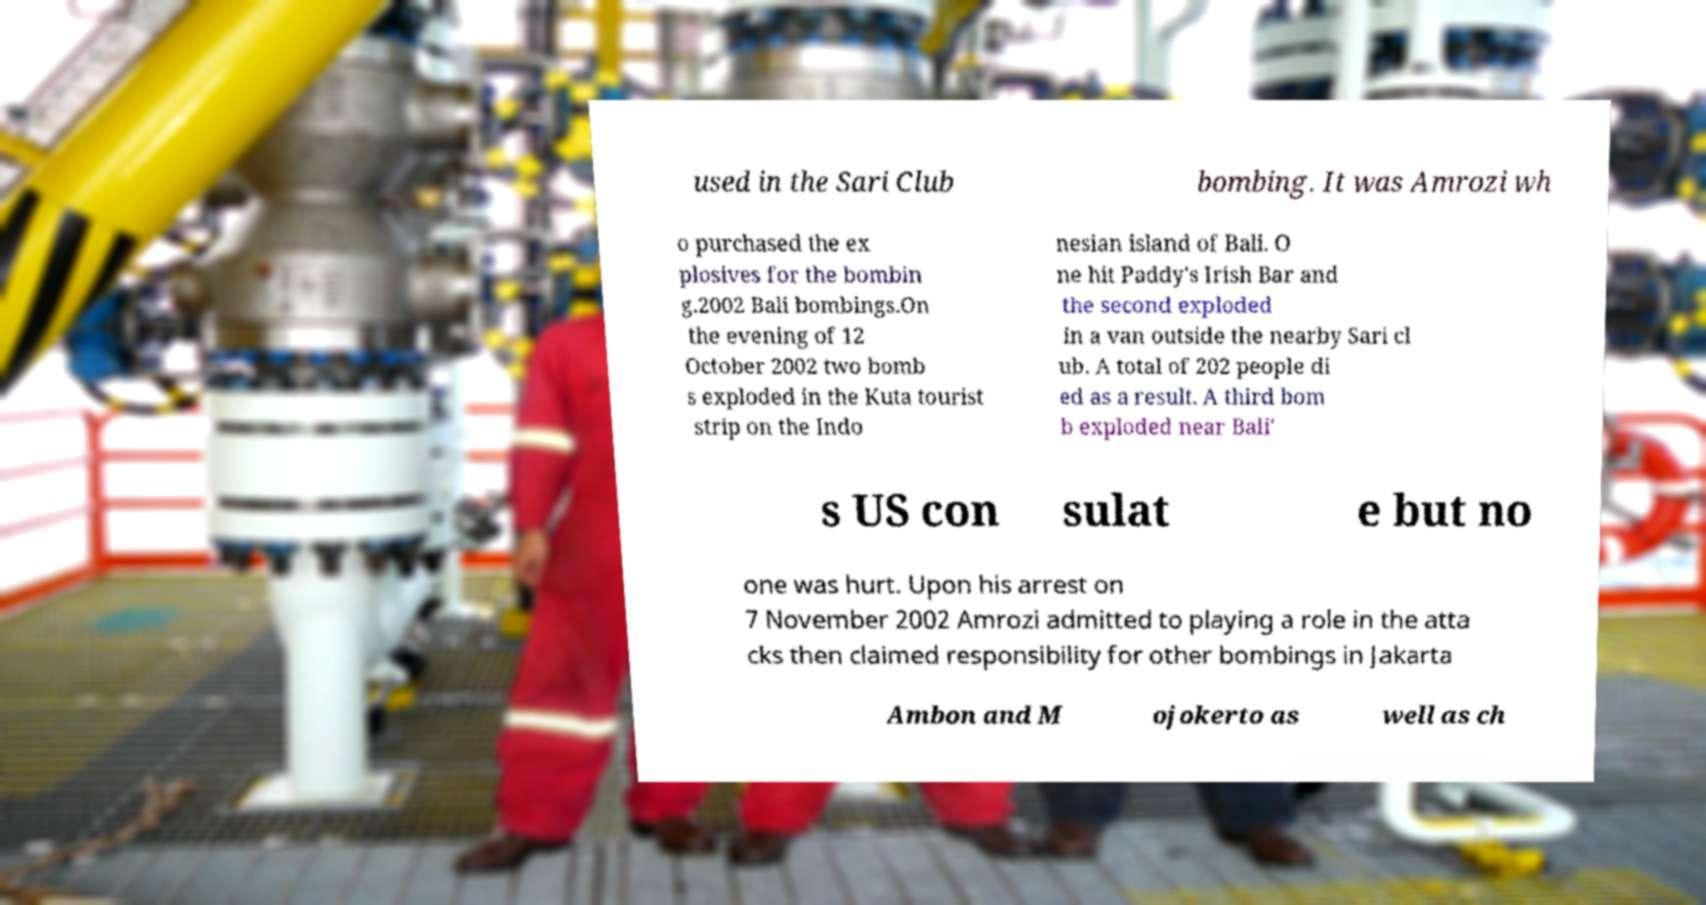Could you assist in decoding the text presented in this image and type it out clearly? used in the Sari Club bombing. It was Amrozi wh o purchased the ex plosives for the bombin g.2002 Bali bombings.On the evening of 12 October 2002 two bomb s exploded in the Kuta tourist strip on the Indo nesian island of Bali. O ne hit Paddy's Irish Bar and the second exploded in a van outside the nearby Sari cl ub. A total of 202 people di ed as a result. A third bom b exploded near Bali' s US con sulat e but no one was hurt. Upon his arrest on 7 November 2002 Amrozi admitted to playing a role in the atta cks then claimed responsibility for other bombings in Jakarta Ambon and M ojokerto as well as ch 